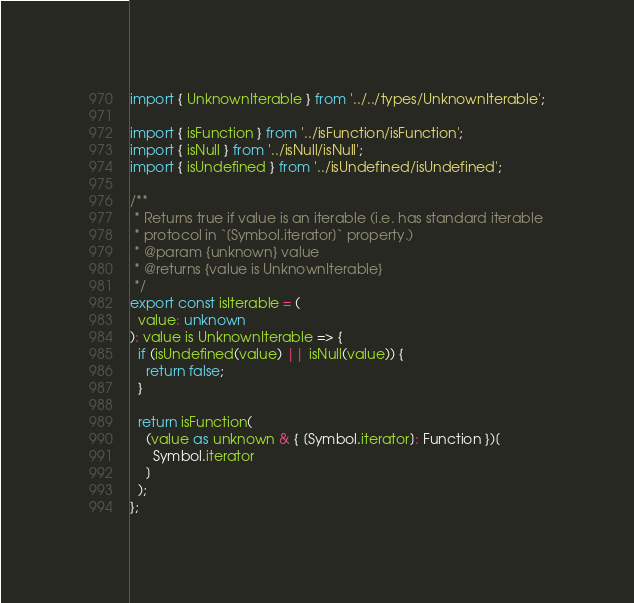Convert code to text. <code><loc_0><loc_0><loc_500><loc_500><_TypeScript_>import { UnknownIterable } from '../../types/UnknownIterable';

import { isFunction } from '../isFunction/isFunction';
import { isNull } from '../isNull/isNull';
import { isUndefined } from '../isUndefined/isUndefined';

/**
 * Returns true if value is an iterable (i.e. has standard iterable
 * protocol in `[Symbol.iterator]` property.)
 * @param {unknown} value
 * @returns {value is UnknownIterable}
 */
export const isIterable = (
  value: unknown
): value is UnknownIterable => {
  if (isUndefined(value) || isNull(value)) {
    return false;
  }

  return isFunction(
    (value as unknown & { [Symbol.iterator]: Function })[
      Symbol.iterator
    ]
  );
};
</code> 